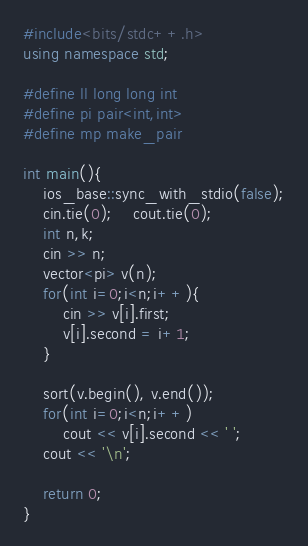Convert code to text. <code><loc_0><loc_0><loc_500><loc_500><_C++_>#include<bits/stdc++.h>
using namespace std;

#define ll long long int
#define pi pair<int,int> 
#define mp make_pair

int main(){
	ios_base::sync_with_stdio(false);
	cin.tie(0);	cout.tie(0);
	int n,k;
	cin >> n;
	vector<pi> v(n);
	for(int i=0;i<n;i++){
		cin >> v[i].first;
		v[i].second = i+1;	
	}

	sort(v.begin(), v.end());
	for(int i=0;i<n;i++)
		cout << v[i].second << ' ';
	cout << '\n';

	return 0;
}</code> 